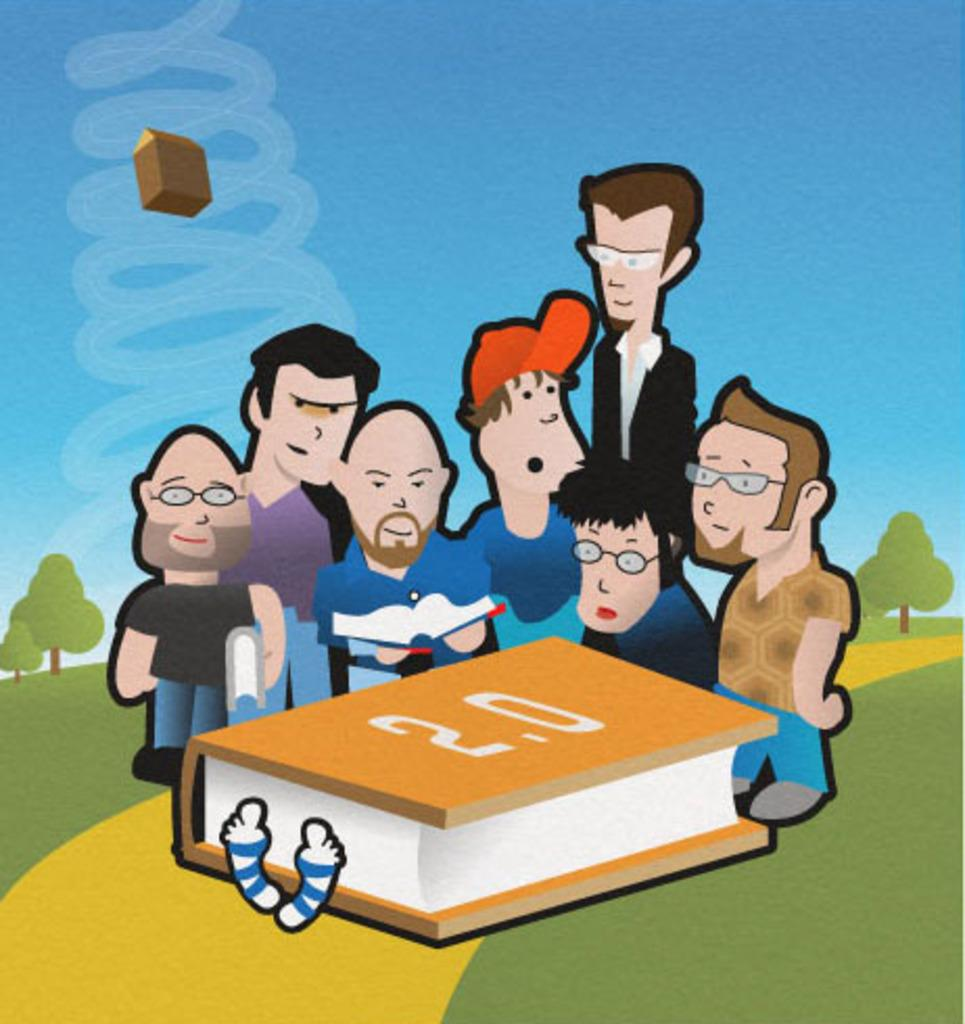What type of image is being described? The image is an animation. What can be seen in the foreground of the image? There are people standing in the image. What object is located at the bottom of the image? There is a book at the bottom of the image. What type of natural scenery is visible in the background of the image? There are trees in the background of the image. What else can be seen in the background of the image? The sky is visible in the background of the image. What type of pot is being used as a jail for the people in the image? There is no pot or jail present in the image; it features an animation with people standing and a book at the bottom. 